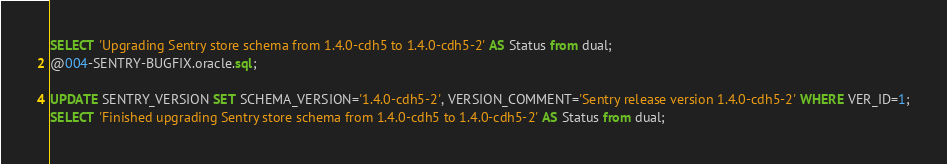<code> <loc_0><loc_0><loc_500><loc_500><_SQL_>SELECT 'Upgrading Sentry store schema from 1.4.0-cdh5 to 1.4.0-cdh5-2' AS Status from dual;
@004-SENTRY-BUGFIX.oracle.sql;

UPDATE SENTRY_VERSION SET SCHEMA_VERSION='1.4.0-cdh5-2', VERSION_COMMENT='Sentry release version 1.4.0-cdh5-2' WHERE VER_ID=1;
SELECT 'Finished upgrading Sentry store schema from 1.4.0-cdh5 to 1.4.0-cdh5-2' AS Status from dual;</code> 